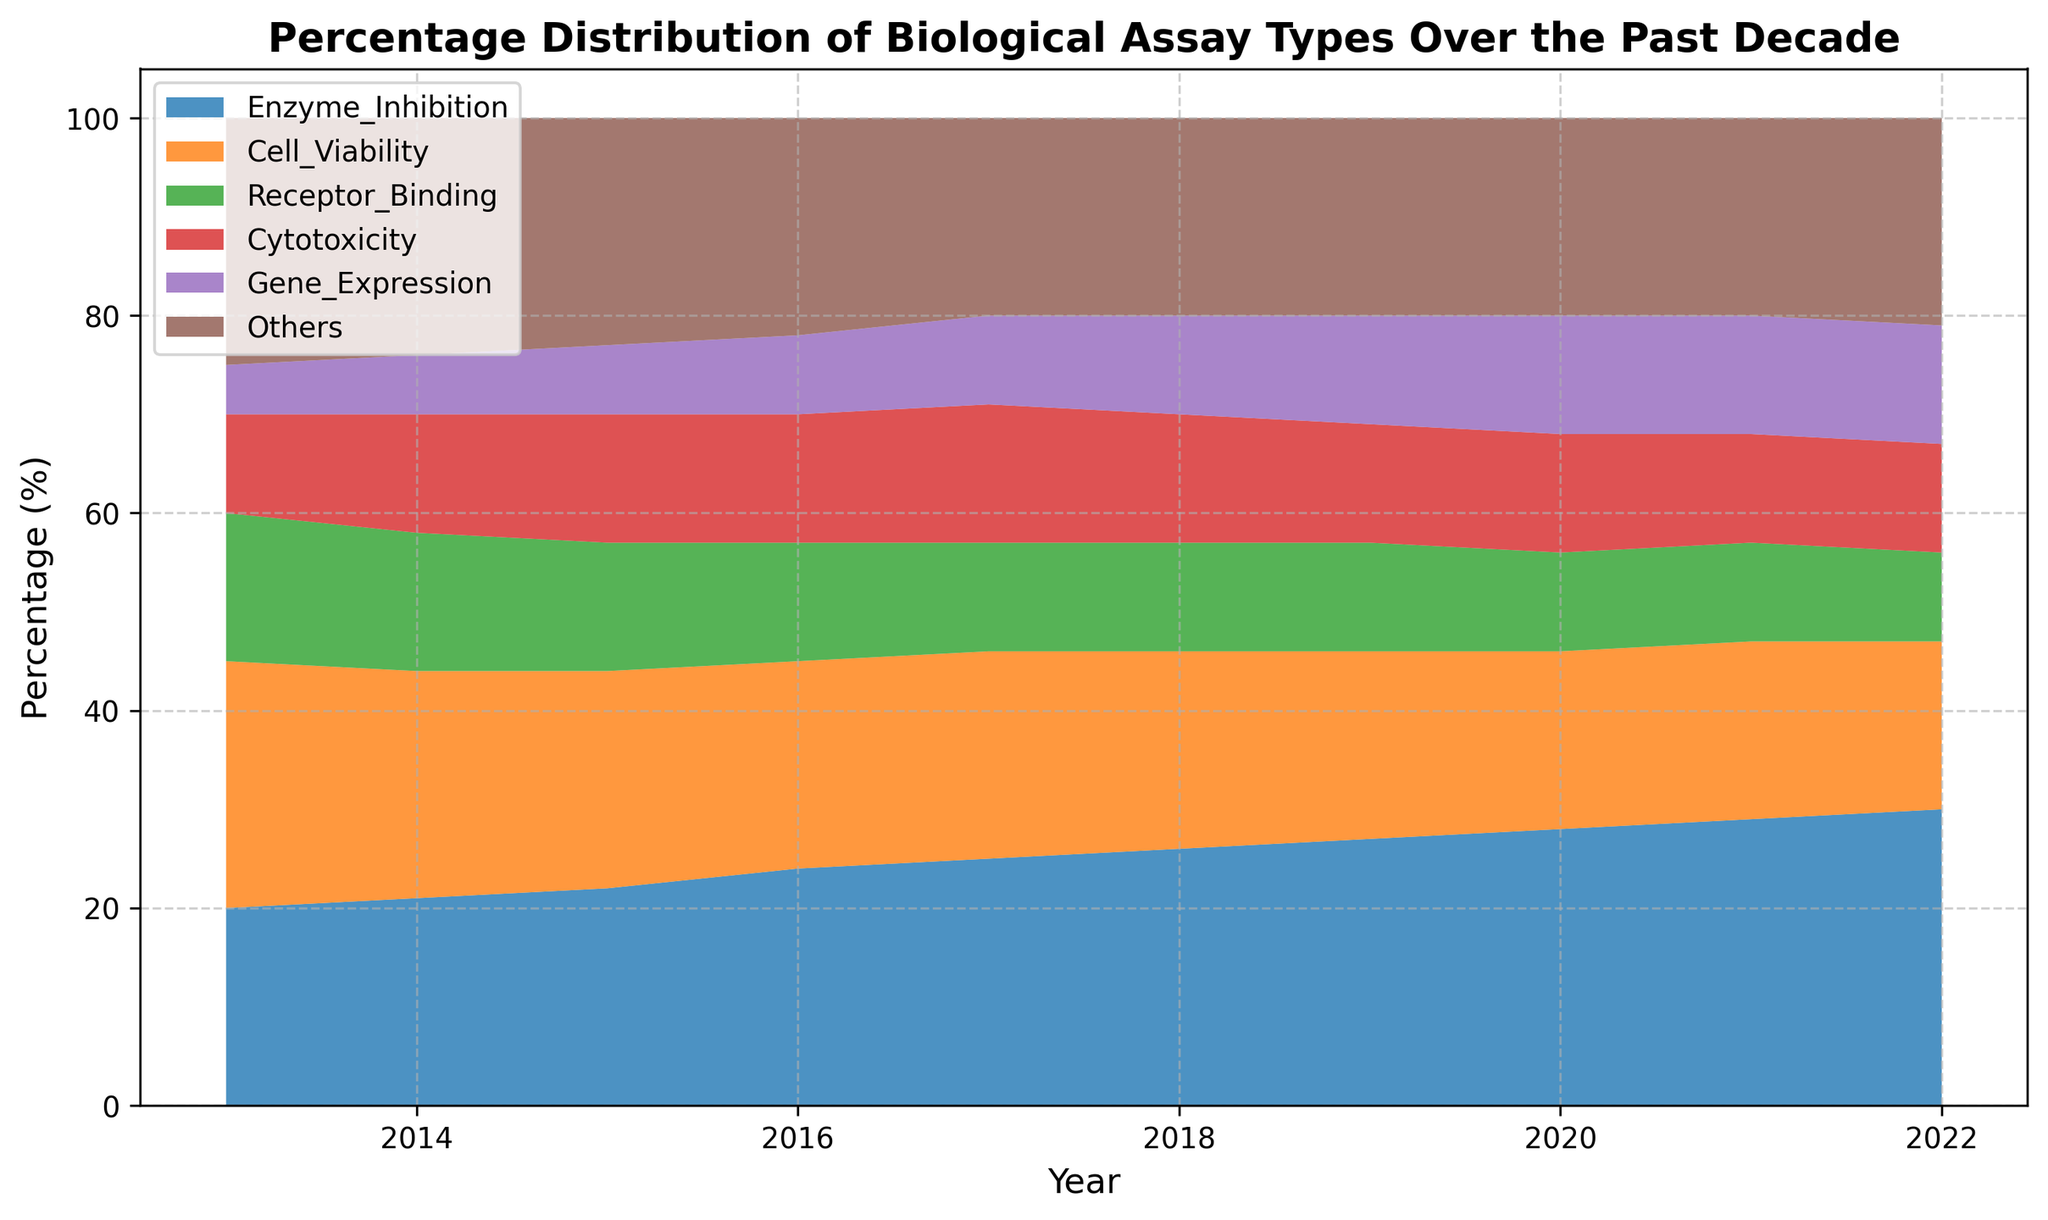What's the predominant assay type in 2022? To determine the predominant assay type in 2022, we look for the highest percentage in that year. According to the data, Enzyme Inhibition shows the highest percentage with 30%.
Answer: Enzyme Inhibition Which assay type showed the largest increase over the past decade? By comparing the values from 2013 to 2022, Enzyme Inhibition went from 20% to 30%, showing an increase of 10 percentage points. This is the largest increase among the assay types.
Answer: Enzyme Inhibition How did the percentage of Cell Viability assays change from 2013 to 2022? The percentage of Cell Viability assays decreased from 25% in 2013 to 17% in 2022. The change is calculated as 25% - 17% = 8% decrease.
Answer: Decreased by 8% Which year had the smallest percentage of Receptor Binding assays? By examining the percentages over the years, we see that in 2022, the percentage of Receptor Binding was at its lowest at 9%.
Answer: 2022 Are Cytotoxicity assays becoming more prevalent over time? By observing the data, the percentage for Cytotoxicity assays increased from 10% in 2013 to 11% in 2017 but then decreased back to 11% in 2022. Overall, there is minor fluctuation but no significant increase over time.
Answer: No significant trend In which year did Gene Expression assays first reach 12%? By checking the data, Gene Expression assays first reached 12% in 2020.
Answer: 2020 What is the combined percentage of 'Others' and 'Gene Expression' assays in 2016? Adding the percentages of 'Others' (22%) and 'Gene Expression' (8%) in 2016 gives a total of 22% + 8% = 30%.
Answer: 30% Which assay type had no change in percentage from 2020 to 2021? Observing the data, 'Others' remained at 20% from 2020 to 2021.
Answer: Others What is the average percentage of Receptor Binding assays between 2013 and 2022? To find the average, sum the percentages of Receptor Binding from 2013 to 2022 (15+14+13+12+11+11+11+10+10+9) = 106, then divide by 10 years. The average is 106/10 = 10.6%.
Answer: 10.6% Did any assay type's percentage remain constant from one year to the next? By inspecting the data, the percentage of Cell Viability remained constant at 18% from 2020 to 2021.
Answer: Yes, Cell Viability 